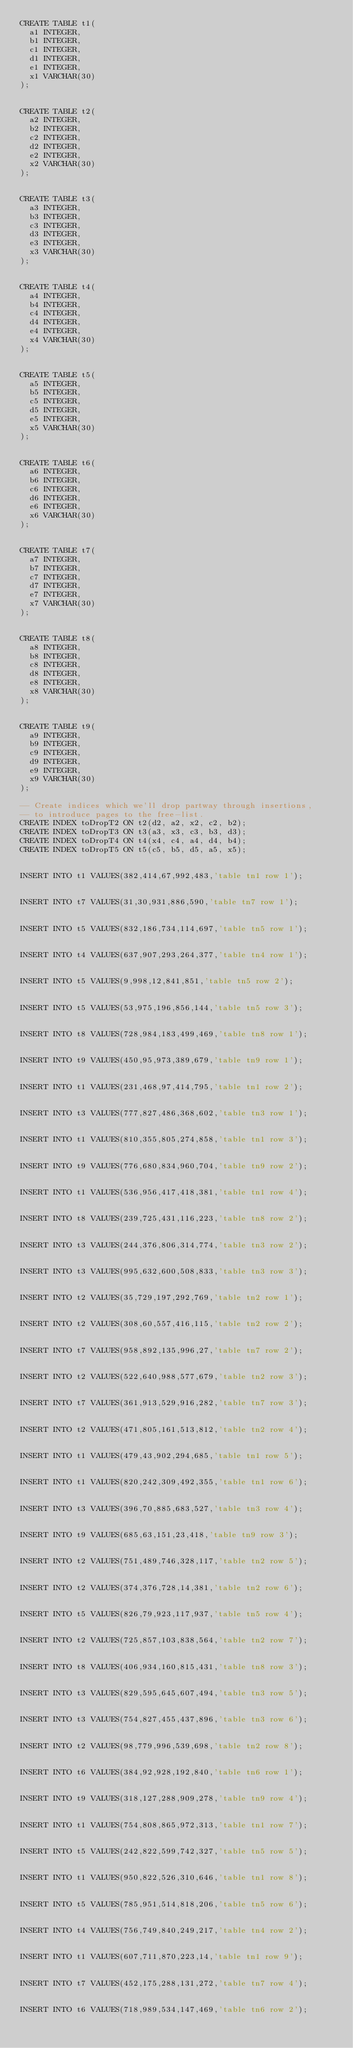Convert code to text. <code><loc_0><loc_0><loc_500><loc_500><_SQL_>CREATE TABLE t1(
  a1 INTEGER,
  b1 INTEGER,
  c1 INTEGER,
  d1 INTEGER,
  e1 INTEGER,
  x1 VARCHAR(30)
);


CREATE TABLE t2(
  a2 INTEGER,
  b2 INTEGER,
  c2 INTEGER,
  d2 INTEGER,
  e2 INTEGER,
  x2 VARCHAR(30)
);


CREATE TABLE t3(
  a3 INTEGER,
  b3 INTEGER,
  c3 INTEGER,
  d3 INTEGER,
  e3 INTEGER,
  x3 VARCHAR(30)
);


CREATE TABLE t4(
  a4 INTEGER,
  b4 INTEGER,
  c4 INTEGER,
  d4 INTEGER,
  e4 INTEGER,
  x4 VARCHAR(30)
);


CREATE TABLE t5(
  a5 INTEGER,
  b5 INTEGER,
  c5 INTEGER,
  d5 INTEGER,
  e5 INTEGER,
  x5 VARCHAR(30)
);


CREATE TABLE t6(
  a6 INTEGER,
  b6 INTEGER,
  c6 INTEGER,
  d6 INTEGER,
  e6 INTEGER,
  x6 VARCHAR(30)
);


CREATE TABLE t7(
  a7 INTEGER,
  b7 INTEGER,
  c7 INTEGER,
  d7 INTEGER,
  e7 INTEGER,
  x7 VARCHAR(30)
);


CREATE TABLE t8(
  a8 INTEGER,
  b8 INTEGER,
  c8 INTEGER,
  d8 INTEGER,
  e8 INTEGER,
  x8 VARCHAR(30)
);


CREATE TABLE t9(
  a9 INTEGER,
  b9 INTEGER,
  c9 INTEGER,
  d9 INTEGER,
  e9 INTEGER,
  x9 VARCHAR(30)
);

-- Create indices which we'll drop partway through insertions,
-- to introduce pages to the free-list. 
CREATE INDEX toDropT2 ON t2(d2, a2, x2, c2, b2);
CREATE INDEX toDropT3 ON t3(a3, x3, c3, b3, d3);
CREATE INDEX toDropT4 ON t4(x4, c4, a4, d4, b4);
CREATE INDEX toDropT5 ON t5(c5, b5, d5, a5, x5);


INSERT INTO t1 VALUES(382,414,67,992,483,'table tn1 row 1');


INSERT INTO t7 VALUES(31,30,931,886,590,'table tn7 row 1');


INSERT INTO t5 VALUES(832,186,734,114,697,'table tn5 row 1');


INSERT INTO t4 VALUES(637,907,293,264,377,'table tn4 row 1');


INSERT INTO t5 VALUES(9,998,12,841,851,'table tn5 row 2');


INSERT INTO t5 VALUES(53,975,196,856,144,'table tn5 row 3');


INSERT INTO t8 VALUES(728,984,183,499,469,'table tn8 row 1');


INSERT INTO t9 VALUES(450,95,973,389,679,'table tn9 row 1');


INSERT INTO t1 VALUES(231,468,97,414,795,'table tn1 row 2');


INSERT INTO t3 VALUES(777,827,486,368,602,'table tn3 row 1');


INSERT INTO t1 VALUES(810,355,805,274,858,'table tn1 row 3');


INSERT INTO t9 VALUES(776,680,834,960,704,'table tn9 row 2');


INSERT INTO t1 VALUES(536,956,417,418,381,'table tn1 row 4');


INSERT INTO t8 VALUES(239,725,431,116,223,'table tn8 row 2');


INSERT INTO t3 VALUES(244,376,806,314,774,'table tn3 row 2');


INSERT INTO t3 VALUES(995,632,600,508,833,'table tn3 row 3');


INSERT INTO t2 VALUES(35,729,197,292,769,'table tn2 row 1');


INSERT INTO t2 VALUES(308,60,557,416,115,'table tn2 row 2');


INSERT INTO t7 VALUES(958,892,135,996,27,'table tn7 row 2');


INSERT INTO t2 VALUES(522,640,988,577,679,'table tn2 row 3');


INSERT INTO t7 VALUES(361,913,529,916,282,'table tn7 row 3');


INSERT INTO t2 VALUES(471,805,161,513,812,'table tn2 row 4');


INSERT INTO t1 VALUES(479,43,902,294,685,'table tn1 row 5');


INSERT INTO t1 VALUES(820,242,309,492,355,'table tn1 row 6');


INSERT INTO t3 VALUES(396,70,885,683,527,'table tn3 row 4');


INSERT INTO t9 VALUES(685,63,151,23,418,'table tn9 row 3');


INSERT INTO t2 VALUES(751,489,746,328,117,'table tn2 row 5');


INSERT INTO t2 VALUES(374,376,728,14,381,'table tn2 row 6');


INSERT INTO t5 VALUES(826,79,923,117,937,'table tn5 row 4');


INSERT INTO t2 VALUES(725,857,103,838,564,'table tn2 row 7');


INSERT INTO t8 VALUES(406,934,160,815,431,'table tn8 row 3');


INSERT INTO t3 VALUES(829,595,645,607,494,'table tn3 row 5');


INSERT INTO t3 VALUES(754,827,455,437,896,'table tn3 row 6');


INSERT INTO t2 VALUES(98,779,996,539,698,'table tn2 row 8');


INSERT INTO t6 VALUES(384,92,928,192,840,'table tn6 row 1');


INSERT INTO t9 VALUES(318,127,288,909,278,'table tn9 row 4');


INSERT INTO t1 VALUES(754,808,865,972,313,'table tn1 row 7');


INSERT INTO t5 VALUES(242,822,599,742,327,'table tn5 row 5');


INSERT INTO t1 VALUES(950,822,526,310,646,'table tn1 row 8');


INSERT INTO t5 VALUES(785,951,514,818,206,'table tn5 row 6');


INSERT INTO t4 VALUES(756,749,840,249,217,'table tn4 row 2');


INSERT INTO t1 VALUES(607,711,870,223,14,'table tn1 row 9');


INSERT INTO t7 VALUES(452,175,288,131,272,'table tn7 row 4');


INSERT INTO t6 VALUES(718,989,534,147,469,'table tn6 row 2');

</code> 